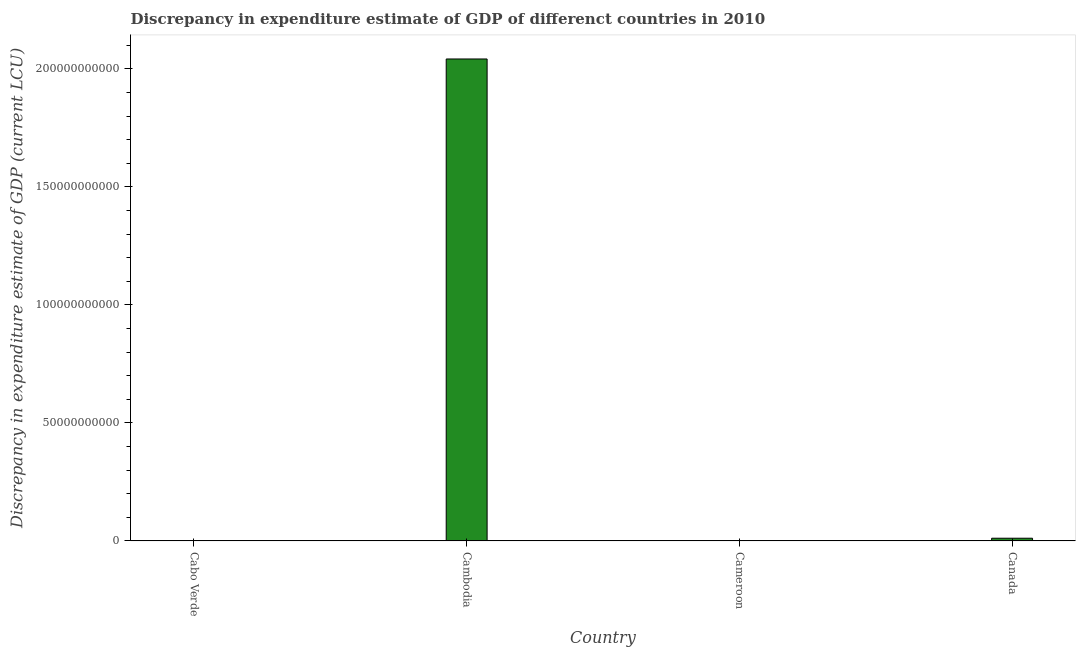Does the graph contain grids?
Your answer should be very brief. No. What is the title of the graph?
Your answer should be very brief. Discrepancy in expenditure estimate of GDP of differenct countries in 2010. What is the label or title of the Y-axis?
Provide a succinct answer. Discrepancy in expenditure estimate of GDP (current LCU). What is the discrepancy in expenditure estimate of gdp in Cambodia?
Your response must be concise. 2.04e+11. Across all countries, what is the maximum discrepancy in expenditure estimate of gdp?
Provide a short and direct response. 2.04e+11. In which country was the discrepancy in expenditure estimate of gdp maximum?
Make the answer very short. Cambodia. What is the sum of the discrepancy in expenditure estimate of gdp?
Provide a short and direct response. 2.05e+11. What is the difference between the discrepancy in expenditure estimate of gdp in Cambodia and Cameroon?
Your response must be concise. 2.04e+11. What is the average discrepancy in expenditure estimate of gdp per country?
Provide a succinct answer. 5.13e+1. What is the median discrepancy in expenditure estimate of gdp?
Give a very brief answer. 5.73e+08. In how many countries, is the discrepancy in expenditure estimate of gdp greater than 80000000000 LCU?
Your answer should be very brief. 1. What is the ratio of the discrepancy in expenditure estimate of gdp in Cambodia to that in Canada?
Give a very brief answer. 178.16. Is the difference between the discrepancy in expenditure estimate of gdp in Cambodia and Cameroon greater than the difference between any two countries?
Provide a short and direct response. No. What is the difference between the highest and the second highest discrepancy in expenditure estimate of gdp?
Make the answer very short. 2.03e+11. What is the difference between the highest and the lowest discrepancy in expenditure estimate of gdp?
Give a very brief answer. 2.04e+11. In how many countries, is the discrepancy in expenditure estimate of gdp greater than the average discrepancy in expenditure estimate of gdp taken over all countries?
Your response must be concise. 1. How many bars are there?
Provide a short and direct response. 3. Are all the bars in the graph horizontal?
Give a very brief answer. No. How many countries are there in the graph?
Give a very brief answer. 4. Are the values on the major ticks of Y-axis written in scientific E-notation?
Your response must be concise. No. What is the Discrepancy in expenditure estimate of GDP (current LCU) in Cabo Verde?
Your answer should be very brief. 0. What is the Discrepancy in expenditure estimate of GDP (current LCU) of Cambodia?
Your answer should be very brief. 2.04e+11. What is the Discrepancy in expenditure estimate of GDP (current LCU) in Cameroon?
Give a very brief answer. 0. What is the Discrepancy in expenditure estimate of GDP (current LCU) in Canada?
Your response must be concise. 1.15e+09. What is the difference between the Discrepancy in expenditure estimate of GDP (current LCU) in Cambodia and Cameroon?
Keep it short and to the point. 2.04e+11. What is the difference between the Discrepancy in expenditure estimate of GDP (current LCU) in Cambodia and Canada?
Offer a terse response. 2.03e+11. What is the difference between the Discrepancy in expenditure estimate of GDP (current LCU) in Cameroon and Canada?
Offer a very short reply. -1.15e+09. What is the ratio of the Discrepancy in expenditure estimate of GDP (current LCU) in Cambodia to that in Cameroon?
Your answer should be very brief. 1.02e+15. What is the ratio of the Discrepancy in expenditure estimate of GDP (current LCU) in Cambodia to that in Canada?
Give a very brief answer. 178.16. What is the ratio of the Discrepancy in expenditure estimate of GDP (current LCU) in Cameroon to that in Canada?
Your answer should be very brief. 0. 